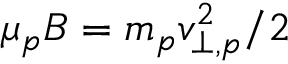<formula> <loc_0><loc_0><loc_500><loc_500>\mu _ { p } B = m _ { p } v _ { \perp , p } ^ { 2 } / 2</formula> 